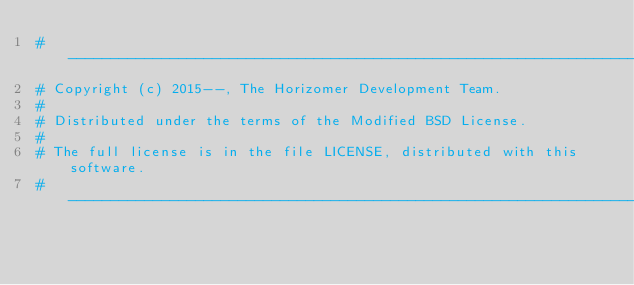<code> <loc_0><loc_0><loc_500><loc_500><_Python_># ----------------------------------------------------------------------------
# Copyright (c) 2015--, The Horizomer Development Team.
#
# Distributed under the terms of the Modified BSD License.
#
# The full license is in the file LICENSE, distributed with this software.
# ----------------------------------------------------------------------------
</code> 